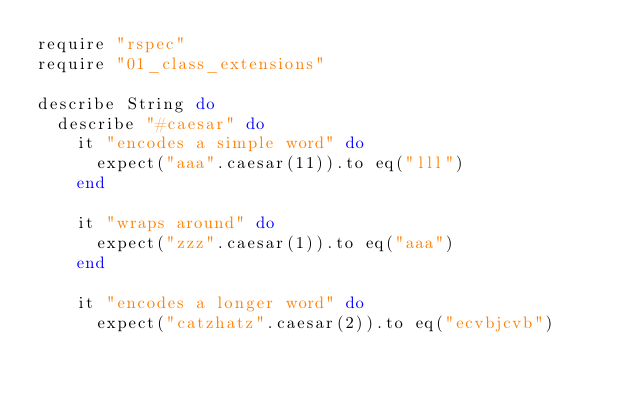<code> <loc_0><loc_0><loc_500><loc_500><_Ruby_>require "rspec"
require "01_class_extensions"

describe String do
  describe "#caesar" do
    it "encodes a simple word" do
      expect("aaa".caesar(11)).to eq("lll")
    end

    it "wraps around" do
      expect("zzz".caesar(1)).to eq("aaa")
    end

    it "encodes a longer word" do
      expect("catzhatz".caesar(2)).to eq("ecvbjcvb")</code> 